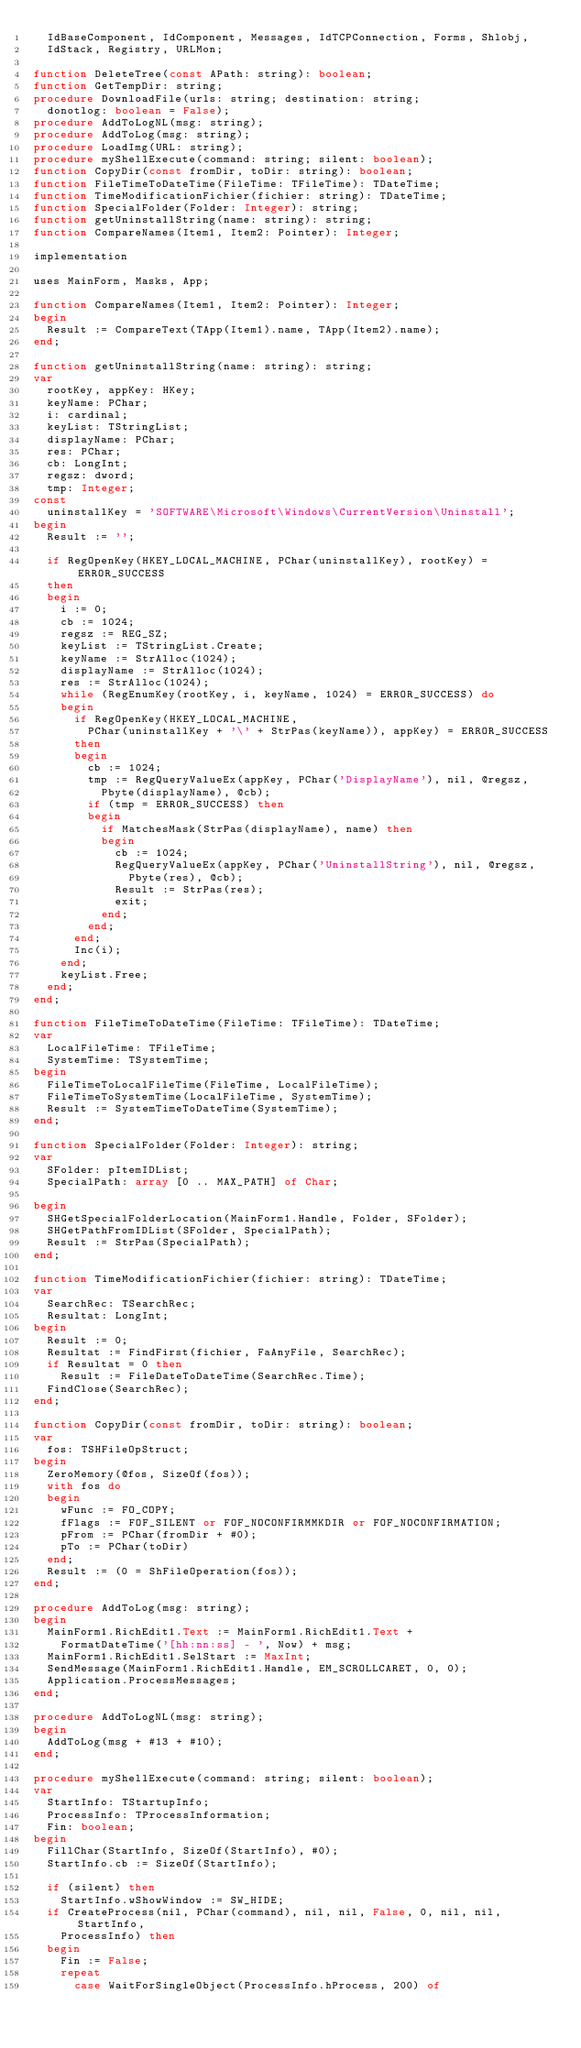<code> <loc_0><loc_0><loc_500><loc_500><_Pascal_>  IdBaseComponent, IdComponent, Messages, IdTCPConnection, Forms, Shlobj,
  IdStack, Registry, URLMon;

function DeleteTree(const APath: string): boolean;
function GetTempDir: string;
procedure DownloadFile(urls: string; destination: string;
  donotlog: boolean = False);
procedure AddToLogNL(msg: string);
procedure AddToLog(msg: string);
procedure LoadImg(URL: string);
procedure myShellExecute(command: string; silent: boolean);
function CopyDir(const fromDir, toDir: string): boolean;
function FileTimeToDateTime(FileTime: TFileTime): TDateTime;
function TimeModificationFichier(fichier: string): TDateTime;
function SpecialFolder(Folder: Integer): string;
function getUninstallString(name: string): string;
function CompareNames(Item1, Item2: Pointer): Integer;

implementation

uses MainForm, Masks, App;

function CompareNames(Item1, Item2: Pointer): Integer;
begin
  Result := CompareText(TApp(Item1).name, TApp(Item2).name);
end;

function getUninstallString(name: string): string;
var
  rootKey, appKey: HKey;
  keyName: PChar;
  i: cardinal;
  keyList: TStringList;
  displayName: PChar;
  res: PChar;
  cb: LongInt;
  regsz: dword;
  tmp: Integer;
const
  uninstallKey = 'SOFTWARE\Microsoft\Windows\CurrentVersion\Uninstall';
begin
  Result := '';

  if RegOpenKey(HKEY_LOCAL_MACHINE, PChar(uninstallKey), rootKey) = ERROR_SUCCESS
  then
  begin
    i := 0;
    cb := 1024;
    regsz := REG_SZ;
    keyList := TStringList.Create;
    keyName := StrAlloc(1024);
    displayName := StrAlloc(1024);
    res := StrAlloc(1024);
    while (RegEnumKey(rootKey, i, keyName, 1024) = ERROR_SUCCESS) do
    begin
      if RegOpenKey(HKEY_LOCAL_MACHINE,
        PChar(uninstallKey + '\' + StrPas(keyName)), appKey) = ERROR_SUCCESS
      then
      begin
        cb := 1024;
        tmp := RegQueryValueEx(appKey, PChar('DisplayName'), nil, @regsz,
          Pbyte(displayName), @cb);
        if (tmp = ERROR_SUCCESS) then
        begin
          if MatchesMask(StrPas(displayName), name) then
          begin
            cb := 1024;
            RegQueryValueEx(appKey, PChar('UninstallString'), nil, @regsz,
              Pbyte(res), @cb);
            Result := StrPas(res);
            exit;
          end;
        end;
      end;
      Inc(i);
    end;
    keyList.Free;
  end;
end;

function FileTimeToDateTime(FileTime: TFileTime): TDateTime;
var
  LocalFileTime: TFileTime;
  SystemTime: TSystemTime;
begin
  FileTimeToLocalFileTime(FileTime, LocalFileTime);
  FileTimeToSystemTime(LocalFileTime, SystemTime);
  Result := SystemTimeToDateTime(SystemTime);
end;

function SpecialFolder(Folder: Integer): string;
var
  SFolder: pItemIDList;
  SpecialPath: array [0 .. MAX_PATH] of Char;

begin
  SHGetSpecialFolderLocation(MainForm1.Handle, Folder, SFolder);
  SHGetPathFromIDList(SFolder, SpecialPath);
  Result := StrPas(SpecialPath);
end;

function TimeModificationFichier(fichier: string): TDateTime;
var
  SearchRec: TSearchRec;
  Resultat: LongInt;
begin
  Result := 0;
  Resultat := FindFirst(fichier, FaAnyFile, SearchRec);
  if Resultat = 0 then
    Result := FileDateToDateTime(SearchRec.Time);
  FindClose(SearchRec);
end;

function CopyDir(const fromDir, toDir: string): boolean;
var
  fos: TSHFileOpStruct;
begin
  ZeroMemory(@fos, SizeOf(fos));
  with fos do
  begin
    wFunc := FO_COPY;
    fFlags := FOF_SILENT or FOF_NOCONFIRMMKDIR or FOF_NOCONFIRMATION;
    pFrom := PChar(fromDir + #0);
    pTo := PChar(toDir)
  end;
  Result := (0 = ShFileOperation(fos));
end;

procedure AddToLog(msg: string);
begin
  MainForm1.RichEdit1.Text := MainForm1.RichEdit1.Text +
    FormatDateTime('[hh:nn:ss] - ', Now) + msg;
  MainForm1.RichEdit1.SelStart := MaxInt;
  SendMessage(MainForm1.RichEdit1.Handle, EM_SCROLLCARET, 0, 0);
  Application.ProcessMessages;
end;

procedure AddToLogNL(msg: string);
begin
  AddToLog(msg + #13 + #10);
end;

procedure myShellExecute(command: string; silent: boolean);
var
  StartInfo: TStartupInfo;
  ProcessInfo: TProcessInformation;
  Fin: boolean;
begin
  FillChar(StartInfo, SizeOf(StartInfo), #0);
  StartInfo.cb := SizeOf(StartInfo);

  if (silent) then
    StartInfo.wShowWindow := SW_HIDE;
  if CreateProcess(nil, PChar(command), nil, nil, False, 0, nil, nil, StartInfo,
    ProcessInfo) then
  begin
    Fin := False;
    repeat
      case WaitForSingleObject(ProcessInfo.hProcess, 200) of</code> 